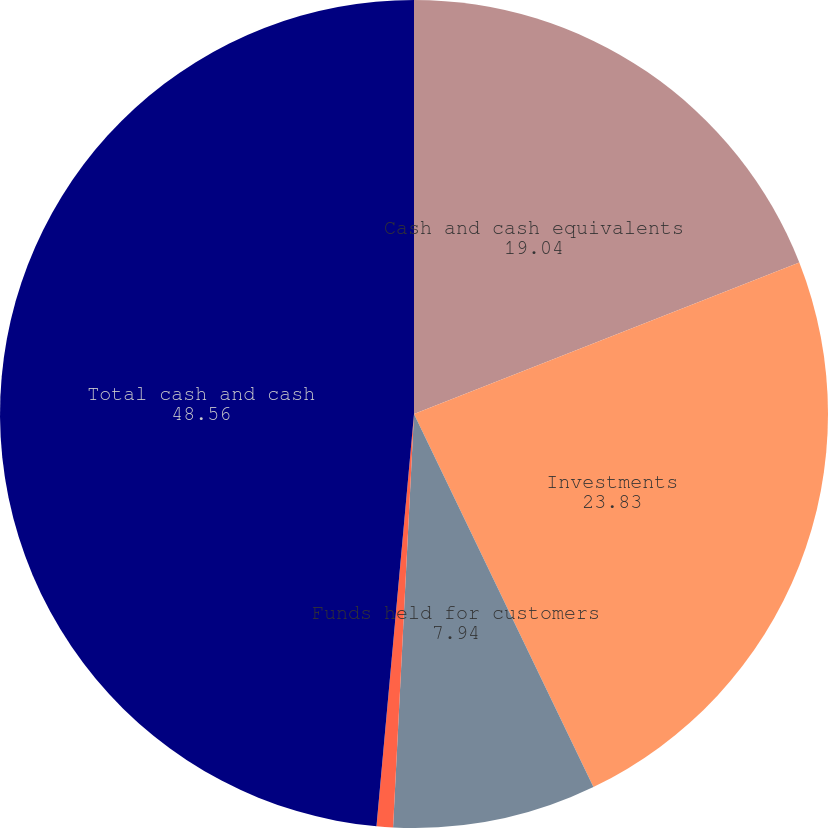Convert chart to OTSL. <chart><loc_0><loc_0><loc_500><loc_500><pie_chart><fcel>Cash and cash equivalents<fcel>Investments<fcel>Funds held for customers<fcel>Long-term investments<fcel>Total cash and cash<nl><fcel>19.04%<fcel>23.83%<fcel>7.94%<fcel>0.64%<fcel>48.56%<nl></chart> 